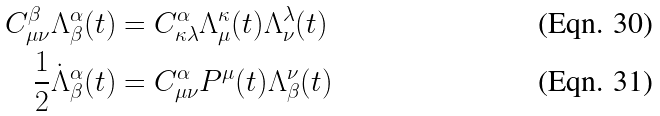<formula> <loc_0><loc_0><loc_500><loc_500>C ^ { \beta } _ { \mu \nu } \Lambda ^ { \alpha } _ { \beta } ( t ) & = C ^ { \alpha } _ { \kappa \lambda } \Lambda ^ { \kappa } _ { \mu } ( t ) \Lambda ^ { \lambda } _ { \nu } ( t ) \\ \frac { 1 } { 2 } \dot { \Lambda } ^ { \alpha } _ { \beta } ( t ) & = C ^ { \alpha } _ { \mu \nu } P ^ { \mu } ( t ) \Lambda ^ { \nu } _ { \beta } ( t )</formula> 